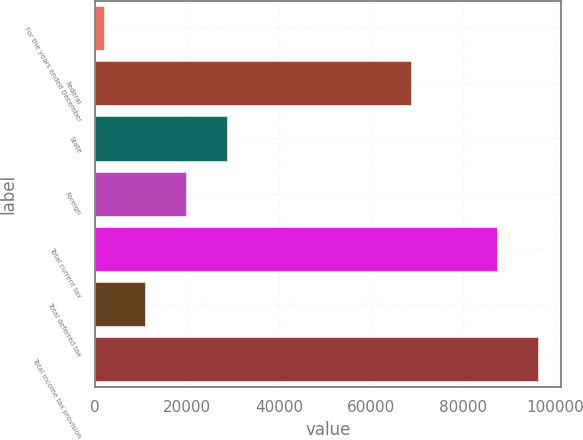<chart> <loc_0><loc_0><loc_500><loc_500><bar_chart><fcel>For the years ended December<fcel>Federal<fcel>State<fcel>Foreign<fcel>Total current tax<fcel>Total deferred tax<fcel>Total income tax provision<nl><fcel>2015<fcel>68667<fcel>28719.2<fcel>19817.8<fcel>87536<fcel>10916.4<fcel>96437.4<nl></chart> 